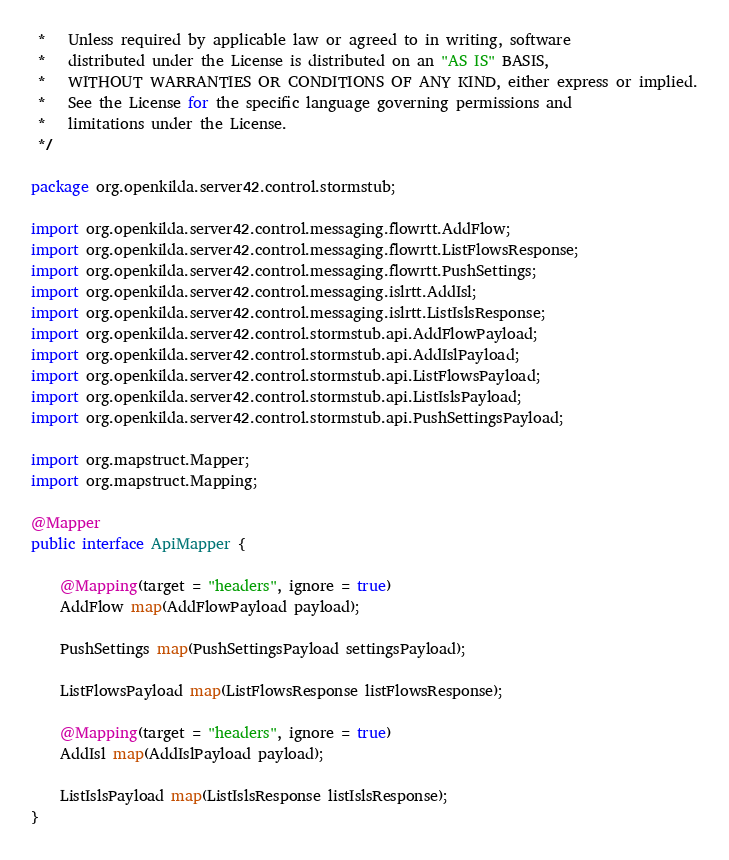Convert code to text. <code><loc_0><loc_0><loc_500><loc_500><_Java_> *   Unless required by applicable law or agreed to in writing, software
 *   distributed under the License is distributed on an "AS IS" BASIS,
 *   WITHOUT WARRANTIES OR CONDITIONS OF ANY KIND, either express or implied.
 *   See the License for the specific language governing permissions and
 *   limitations under the License.
 */

package org.openkilda.server42.control.stormstub;

import org.openkilda.server42.control.messaging.flowrtt.AddFlow;
import org.openkilda.server42.control.messaging.flowrtt.ListFlowsResponse;
import org.openkilda.server42.control.messaging.flowrtt.PushSettings;
import org.openkilda.server42.control.messaging.islrtt.AddIsl;
import org.openkilda.server42.control.messaging.islrtt.ListIslsResponse;
import org.openkilda.server42.control.stormstub.api.AddFlowPayload;
import org.openkilda.server42.control.stormstub.api.AddIslPayload;
import org.openkilda.server42.control.stormstub.api.ListFlowsPayload;
import org.openkilda.server42.control.stormstub.api.ListIslsPayload;
import org.openkilda.server42.control.stormstub.api.PushSettingsPayload;

import org.mapstruct.Mapper;
import org.mapstruct.Mapping;

@Mapper
public interface ApiMapper {

    @Mapping(target = "headers", ignore = true)
    AddFlow map(AddFlowPayload payload);

    PushSettings map(PushSettingsPayload settingsPayload);

    ListFlowsPayload map(ListFlowsResponse listFlowsResponse);

    @Mapping(target = "headers", ignore = true)
    AddIsl map(AddIslPayload payload);

    ListIslsPayload map(ListIslsResponse listIslsResponse);
}
</code> 